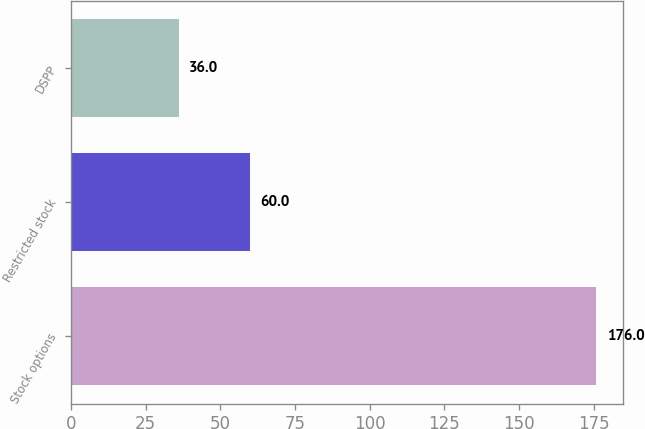Convert chart to OTSL. <chart><loc_0><loc_0><loc_500><loc_500><bar_chart><fcel>Stock options<fcel>Restricted stock<fcel>DSPP<nl><fcel>176<fcel>60<fcel>36<nl></chart> 